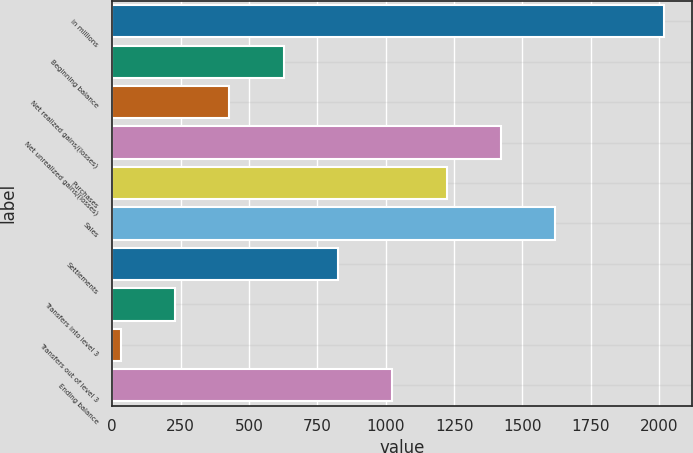Convert chart to OTSL. <chart><loc_0><loc_0><loc_500><loc_500><bar_chart><fcel>in millions<fcel>Beginning balance<fcel>Net realized gains/(losses)<fcel>Net unrealized gains/(losses)<fcel>Purchases<fcel>Sales<fcel>Settlements<fcel>Transfers into level 3<fcel>Transfers out of level 3<fcel>Ending balance<nl><fcel>2018<fcel>627.1<fcel>428.4<fcel>1421.9<fcel>1223.2<fcel>1620.6<fcel>825.8<fcel>229.7<fcel>31<fcel>1024.5<nl></chart> 